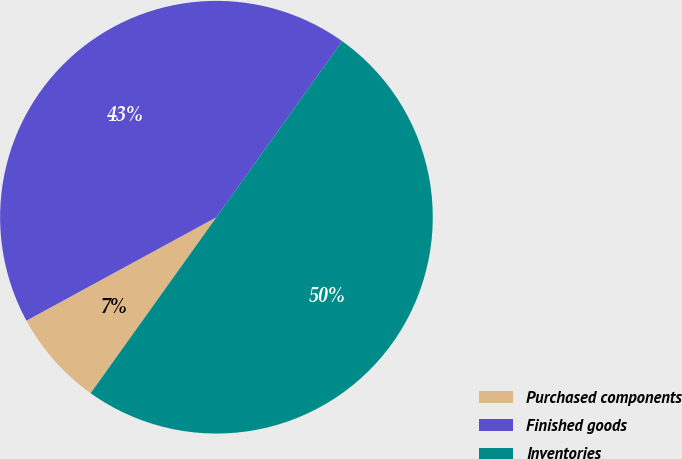<chart> <loc_0><loc_0><loc_500><loc_500><pie_chart><fcel>Purchased components<fcel>Finished goods<fcel>Inventories<nl><fcel>7.19%<fcel>42.81%<fcel>50.0%<nl></chart> 